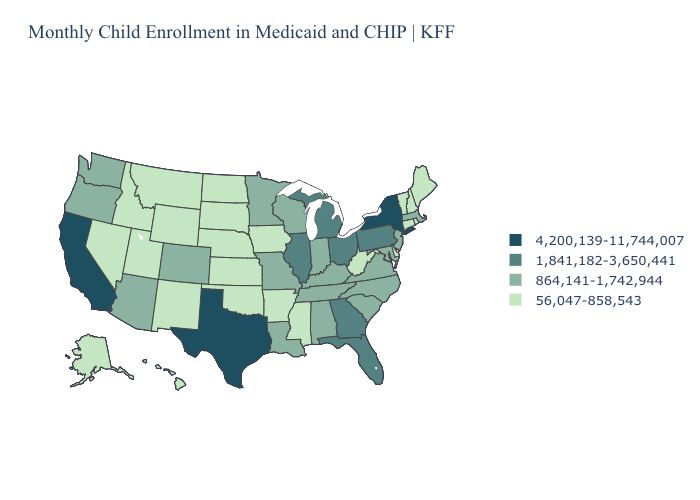Name the states that have a value in the range 1,841,182-3,650,441?
Give a very brief answer. Florida, Georgia, Illinois, Michigan, Ohio, Pennsylvania. What is the value of Michigan?
Keep it brief. 1,841,182-3,650,441. Name the states that have a value in the range 4,200,139-11,744,007?
Quick response, please. California, New York, Texas. What is the lowest value in the MidWest?
Keep it brief. 56,047-858,543. Does the map have missing data?
Concise answer only. No. Does the map have missing data?
Quick response, please. No. Name the states that have a value in the range 864,141-1,742,944?
Quick response, please. Alabama, Arizona, Colorado, Indiana, Kentucky, Louisiana, Maryland, Massachusetts, Minnesota, Missouri, New Jersey, North Carolina, Oregon, South Carolina, Tennessee, Virginia, Washington, Wisconsin. What is the highest value in the MidWest ?
Quick response, please. 1,841,182-3,650,441. Does New York have the highest value in the USA?
Short answer required. Yes. What is the value of North Carolina?
Be succinct. 864,141-1,742,944. Among the states that border Tennessee , does Alabama have the lowest value?
Quick response, please. No. Name the states that have a value in the range 1,841,182-3,650,441?
Keep it brief. Florida, Georgia, Illinois, Michigan, Ohio, Pennsylvania. What is the value of New Hampshire?
Quick response, please. 56,047-858,543. Among the states that border Pennsylvania , does Ohio have the lowest value?
Be succinct. No. Does New Mexico have the highest value in the West?
Answer briefly. No. 